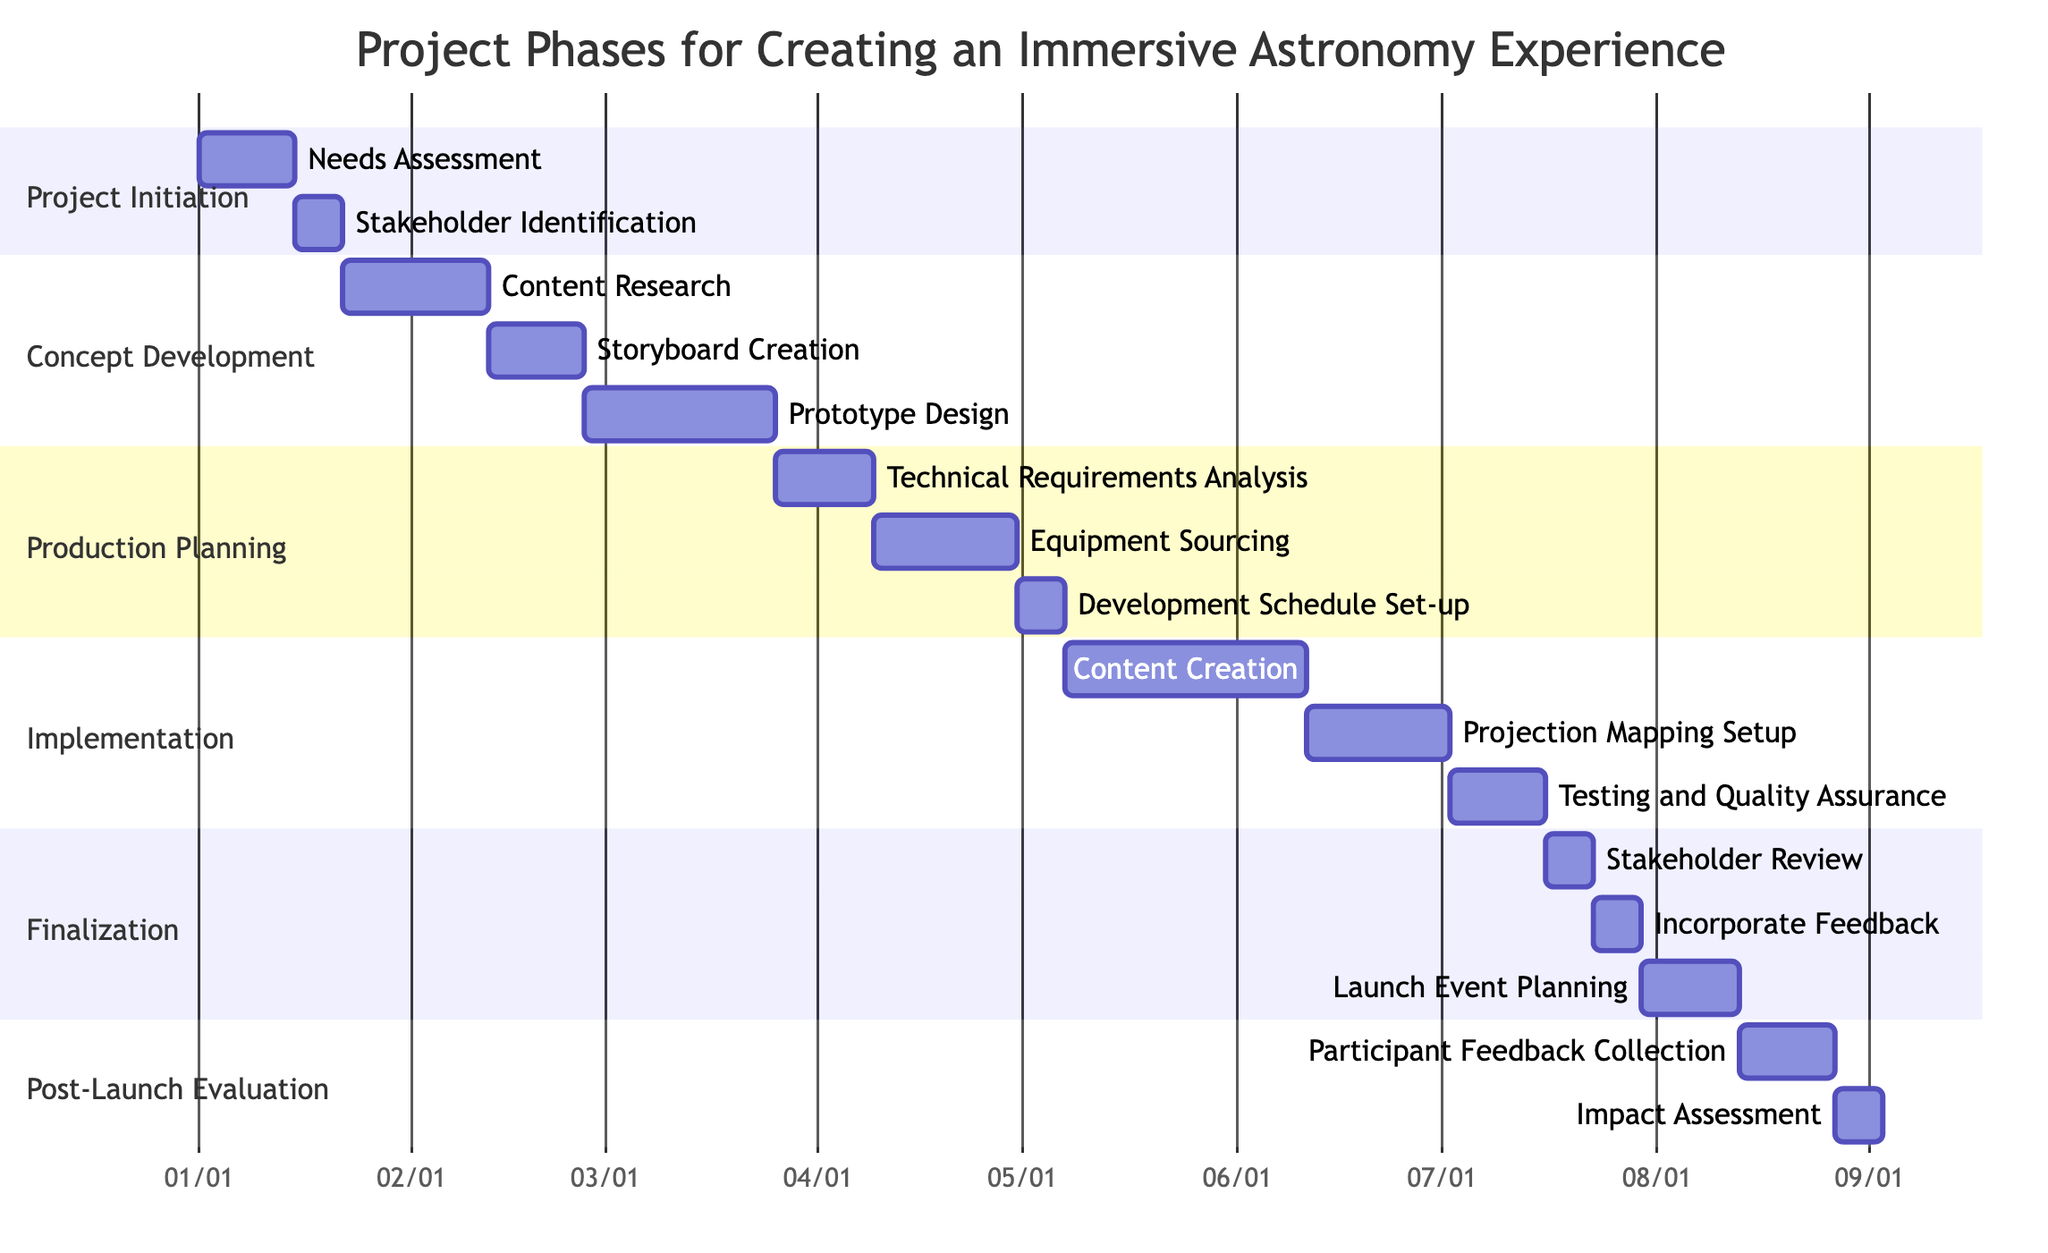What is the duration of the "Needs Assessment" task? The duration of the "Needs Assessment" task is specified in the Gantt chart as "2 weeks."
Answer: 2 weeks How many tasks are in the "Implementation" phase? The "Implementation" phase consists of three tasks: "Content Creation," "Projection Mapping Setup," and "Testing and Quality Assurance." Therefore, there are 3 tasks.
Answer: 3 When does the "Storyboard Creation" task start? The "Storyboard Creation" task starts immediately after the "Content Research" task, which ends on February 11, 2023. Therefore, it starts on February 12, 2023.
Answer: 02/12 Which task has the longest duration in the whole project? Among all the tasks, "Content Creation" has the longest duration of 5 weeks.
Answer: 5 weeks What phase includes the "Equipment Sourcing" task? The "Equipment Sourcing" task is included in the "Production Planning" phase.
Answer: Production Planning If the "Launch Event Planning" takes 2 weeks, when will it be completed? The "Launch Event Planning" task starts on July 30, 2023, and takes 2 weeks to complete, therefore it will be completed on August 13, 2023.
Answer: 08/13 What tasks occur in the "Finalization" phase? The tasks that occur in the "Finalization" phase are "Stakeholder Review," "Incorporate Feedback," and "Launch Event Planning."
Answer: Stakeholder Review, Incorporate Feedback, Launch Event Planning Which task follows the "Testing and Quality Assurance"? The task following "Testing and Quality Assurance" is "Stakeholder Review."
Answer: Stakeholder Review What is the total duration of the "Concept Development" phase? The total duration of the "Concept Development" phase can be calculated by adding the individual durations of its tasks: "Content Research" (3 weeks) + "Storyboard Creation" (2 weeks) + "Prototype Design" (4 weeks) equals 9 weeks.
Answer: 9 weeks 